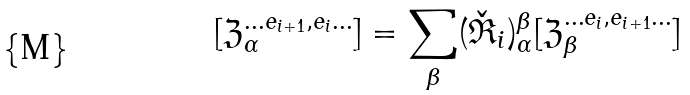Convert formula to latex. <formula><loc_0><loc_0><loc_500><loc_500>[ \mathfrak Z ^ { \dots e _ { i + 1 } , e _ { i } \dots } _ { \alpha } ] = \sum _ { \beta } ( \check { \mathfrak R } _ { i } ) _ { \alpha } ^ { \beta } [ \mathfrak Z ^ { \dots e _ { i } , e _ { i + 1 } \dots } _ { \beta } ]</formula> 